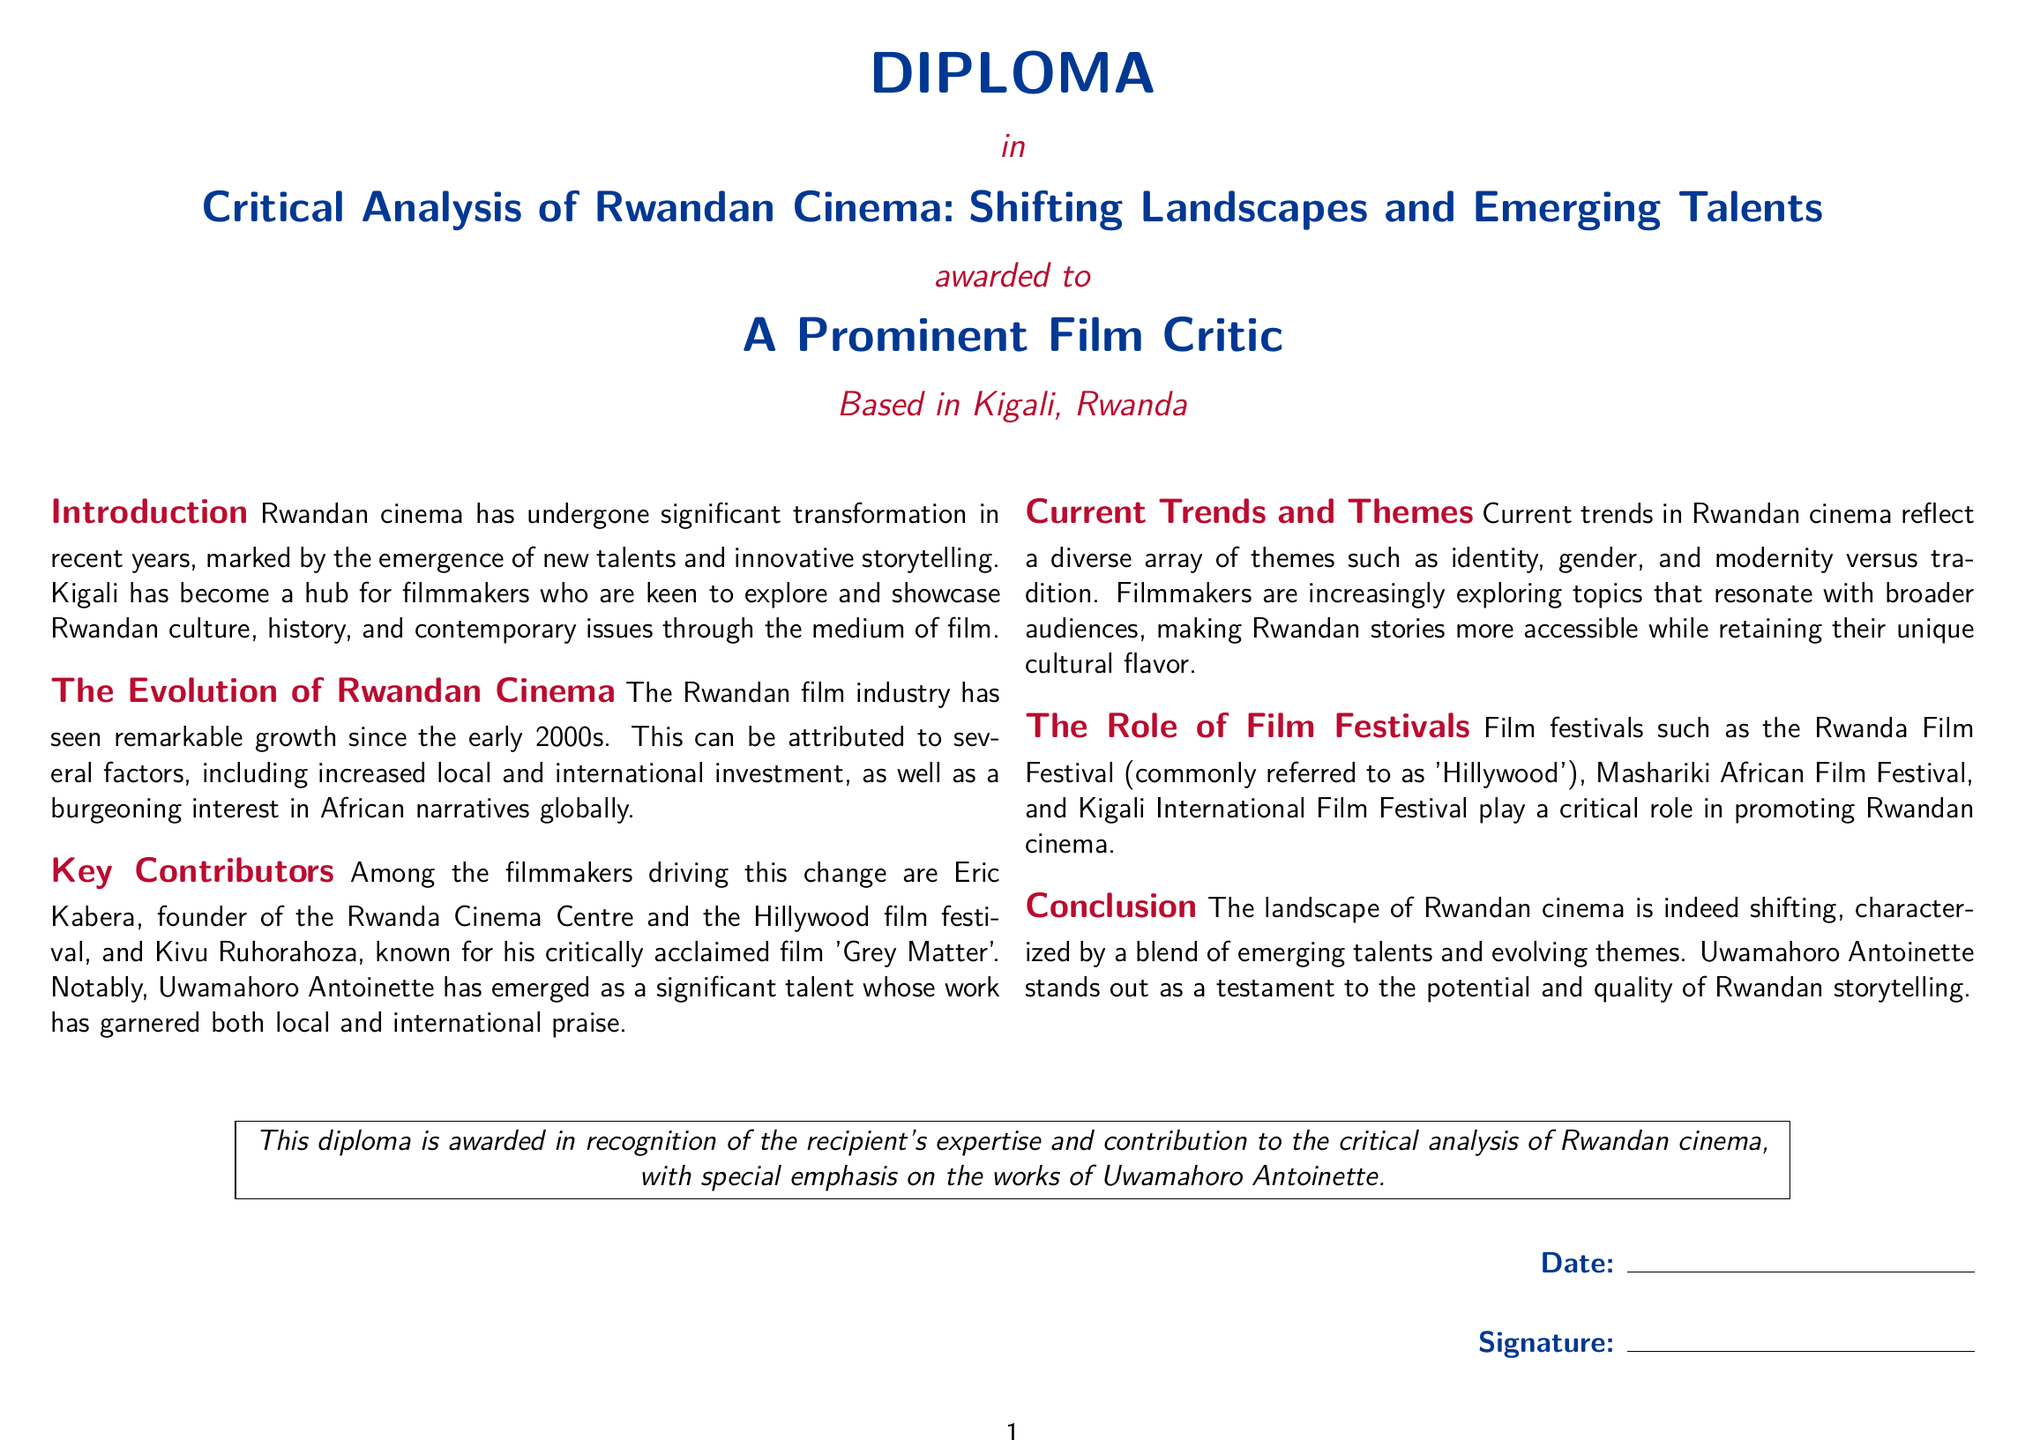What is the title of the diploma? The title of the diploma is explicitly stated as "Critical Analysis of Rwandan Cinema: Shifting Landscapes and Emerging Talents."
Answer: Critical Analysis of Rwandan Cinema: Shifting Landscapes and Emerging Talents Who is the diploma awarded to? The diploma is awarded to "A Prominent Film Critic."
Answer: A Prominent Film Critic What is highlighted about Uwamahoro Antoinette in the document? The document emphasizes her emergence as a significant talent in Rwandan cinema whose work has garnered praise.
Answer: Significant talent In which city is the recipient based? The document mentions that the recipient is based in Kigali, Rwanda.
Answer: Kigali, Rwanda What festival is referred to as 'Hillywood'? The Rwanda Film Festival is commonly referred to as 'Hillywood.'
Answer: Rwanda Film Festival What are some current trends in Rwandan cinema mentioned? The document notes themes such as identity, gender, and modernity versus tradition as current trends.
Answer: Identity, gender, modernity vs tradition Who founded the Rwanda Cinema Centre? Eric Kabera is identified as the founder of the Rwanda Cinema Centre.
Answer: Eric Kabera What does the diploma recognize? It specifically recognizes the recipient's expertise and contribution to the critical analysis of Rwandan cinema.
Answer: Expertise and contribution What is the significance of film festivals according to the document? Film festivals play a critical role in promoting Rwandan cinema.
Answer: Promote Rwandan cinema 